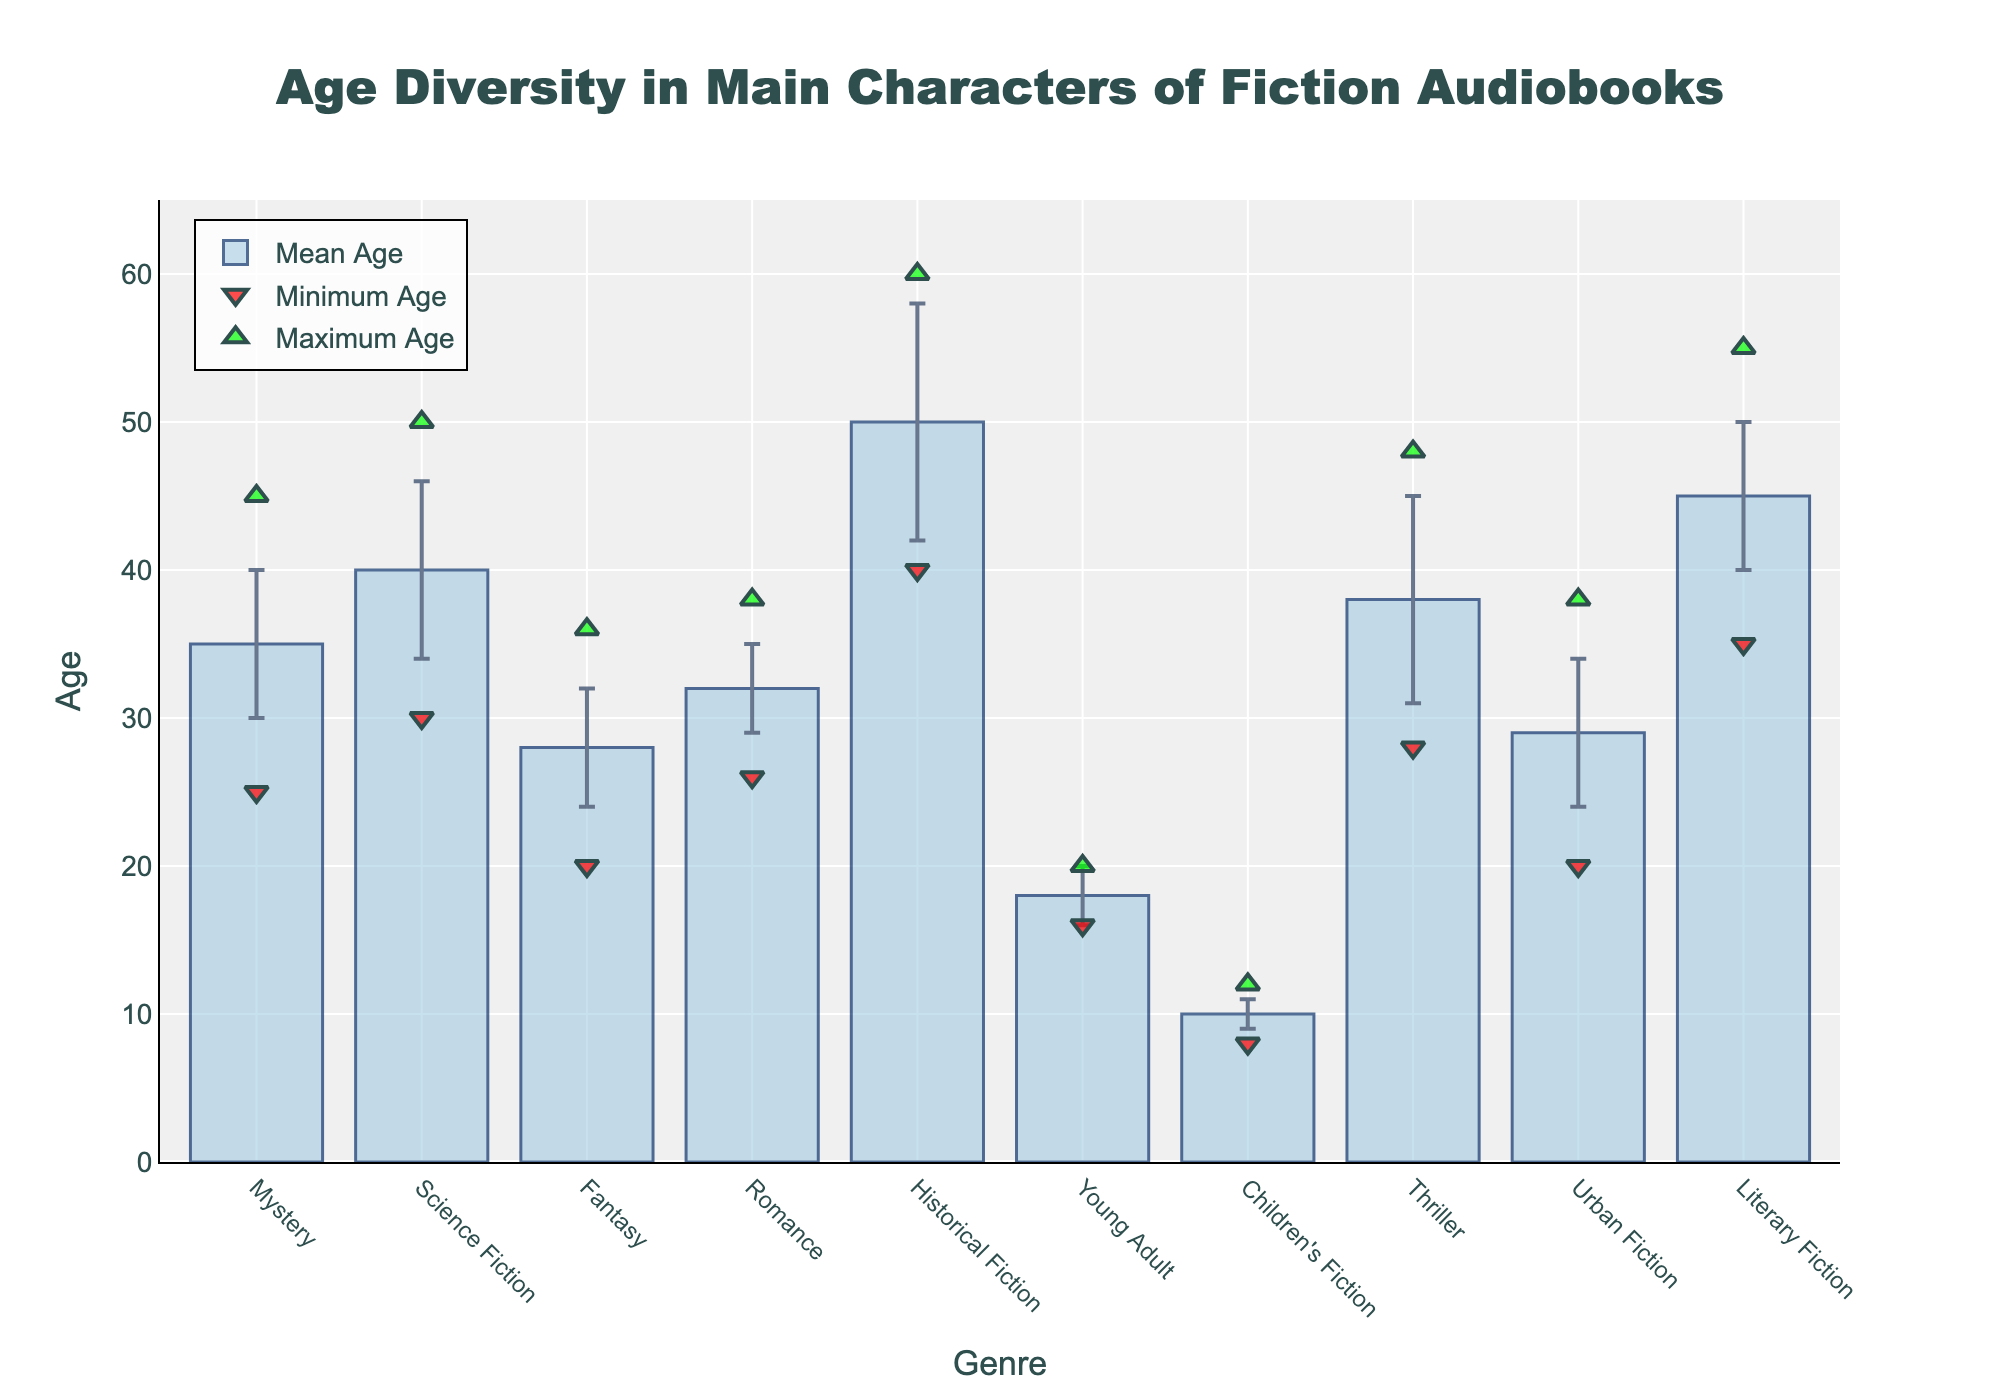What is the mean age of main characters in Mystery audiobooks? The mean age can be found directly on the bar representing the Mystery genre. The bar is labeled at an age of 35.
Answer: 35 What is the title of the figure? The title is displayed at the top of the figure. It reads "Age Diversity in Main Characters of Fiction Audiobooks."
Answer: Age Diversity in Main Characters of Fiction Audiobooks Which genre has the largest standard deviation in the age of main characters? From the error bars, Historical Fiction has the longest error bar indicating the largest standard deviation, which is 8.
Answer: Historical Fiction Which two genres have the smallest mean age and what are those ages? By looking at the bars, Children's Fiction and Young Adult have the smallest mean ages. The Children's Fiction mean age is 10 and the Young Adult mean age is 18.
Answer: Children's Fiction 10, Young Adult 18 Which genre has the widest range in age and what is that range? To find the range, subtract the minimum age from the maximum age for each genre and find the largest difference. Historical Fiction has a maximum age of 60 and a minimum age of 40, which gives a range of 20.
Answer: Historical Fiction 20 What is the difference between the maximum and minimum ages in Fantasy audiobooks? The maximum age is 36 and the minimum age is 20, so the difference is 36 - 20 = 16.
Answer: 16 How does the mean age of Science Fiction compare to that of Romance? The mean age of Science Fiction is 40, while that of Romance is 32, which makes Science Fiction older.
Answer: Science Fiction is older Which genre has the least variability in the age of its main characters and what is the standard deviation? The genre with the shortest error bar is Children's Fiction, with a standard deviation of 1.
Answer: Children's Fiction 1 What is the mean age of main characters across all genres? Add the mean ages of all genres and divide by the number of genres: (35 + 40 + 28 + 32 + 50 + 18 + 10 + 38 + 29 + 45)/10 = 32.5
Answer: 32.5 Which genres have a minimum age of 20 or greater? From the markers indicating minimum ages, the genres are Mystery, Science Fiction, Fantasy, Historical Fiction, Thriller, and Literary Fiction.
Answer: Mystery, Science Fiction, Fantasy, Historical Fiction, Thriller, Literary Fiction 